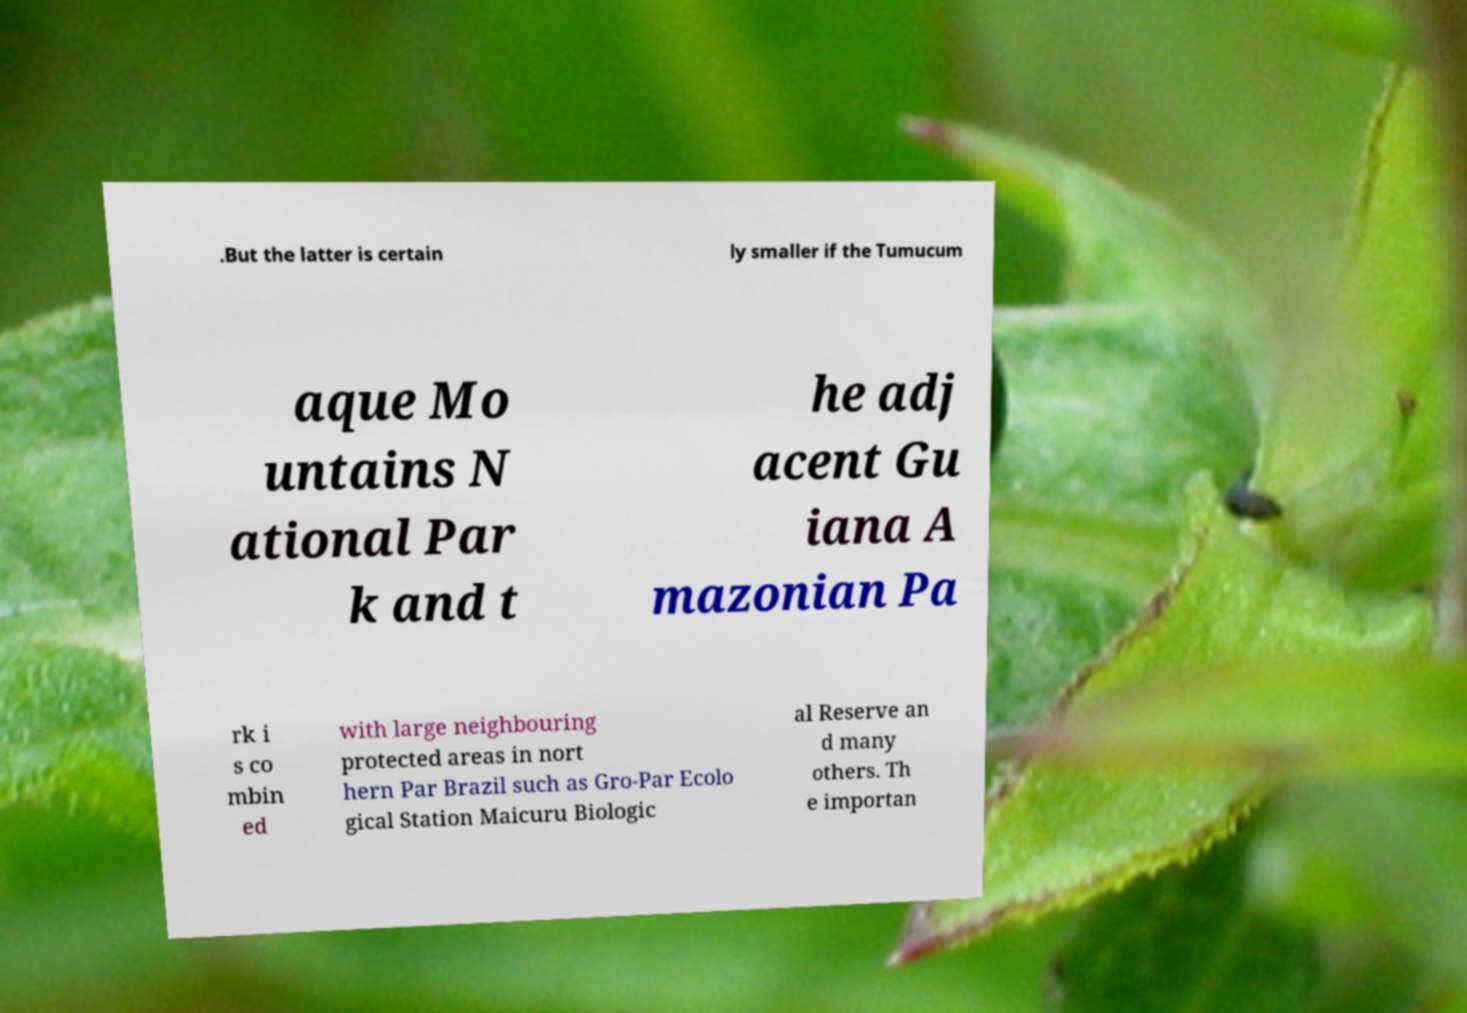Please identify and transcribe the text found in this image. .But the latter is certain ly smaller if the Tumucum aque Mo untains N ational Par k and t he adj acent Gu iana A mazonian Pa rk i s co mbin ed with large neighbouring protected areas in nort hern Par Brazil such as Gro-Par Ecolo gical Station Maicuru Biologic al Reserve an d many others. Th e importan 